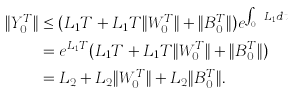Convert formula to latex. <formula><loc_0><loc_0><loc_500><loc_500>\| Y _ { 0 } ^ { T } \| & \leq ( L _ { 1 } T + L _ { 1 } T \| W _ { 0 } ^ { T } \| + \| B _ { 0 } ^ { T } \| ) e ^ { \int _ { 0 } ^ { T } L _ { 1 } d t } \\ & = e ^ { L _ { 1 } T } ( L _ { 1 } T + L _ { 1 } T \| W _ { 0 } ^ { T } \| + \| B _ { 0 } ^ { T } \| ) \\ & = L _ { 2 } + L _ { 2 } \| W _ { 0 } ^ { T } \| + L _ { 2 } \| B _ { 0 } ^ { T } \| .</formula> 